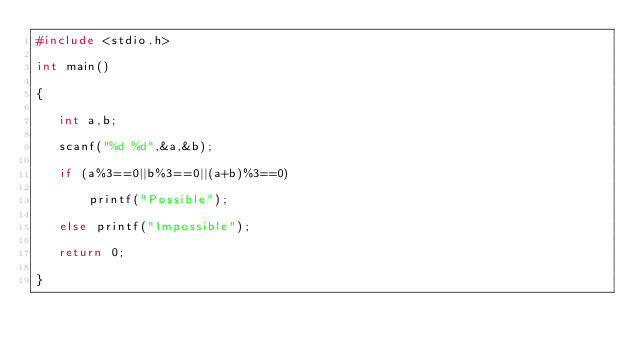<code> <loc_0><loc_0><loc_500><loc_500><_C_>#include <stdio.h>

int main()

{

   int a,b;

   scanf("%d %d",&a,&b);

   if (a%3==0||b%3==0||(a+b)%3==0)

       printf("Possible");

   else printf("Impossible");

   return 0;

}
</code> 